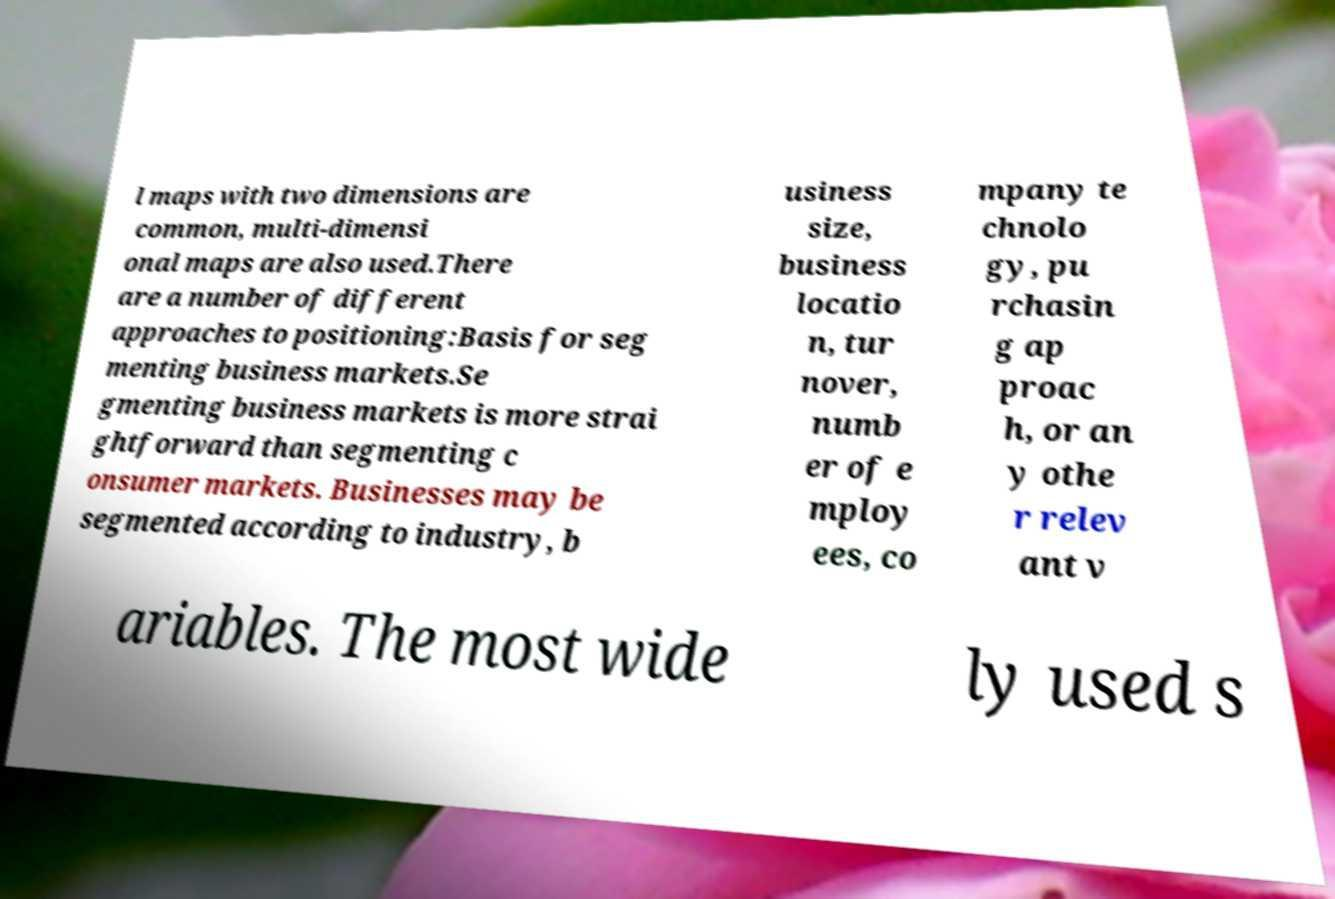I need the written content from this picture converted into text. Can you do that? l maps with two dimensions are common, multi-dimensi onal maps are also used.There are a number of different approaches to positioning:Basis for seg menting business markets.Se gmenting business markets is more strai ghtforward than segmenting c onsumer markets. Businesses may be segmented according to industry, b usiness size, business locatio n, tur nover, numb er of e mploy ees, co mpany te chnolo gy, pu rchasin g ap proac h, or an y othe r relev ant v ariables. The most wide ly used s 